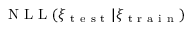Convert formula to latex. <formula><loc_0><loc_0><loc_500><loc_500>N L L ( \xi _ { t e s t } | \xi _ { t r a i n } )</formula> 